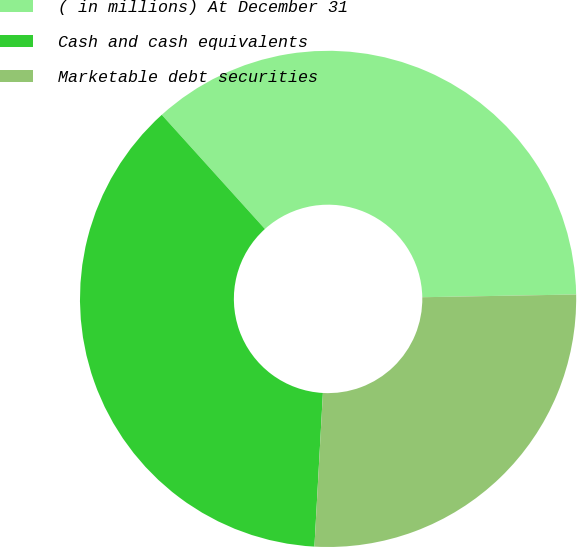<chart> <loc_0><loc_0><loc_500><loc_500><pie_chart><fcel>( in millions) At December 31<fcel>Cash and cash equivalents<fcel>Marketable debt securities<nl><fcel>36.41%<fcel>37.43%<fcel>26.16%<nl></chart> 